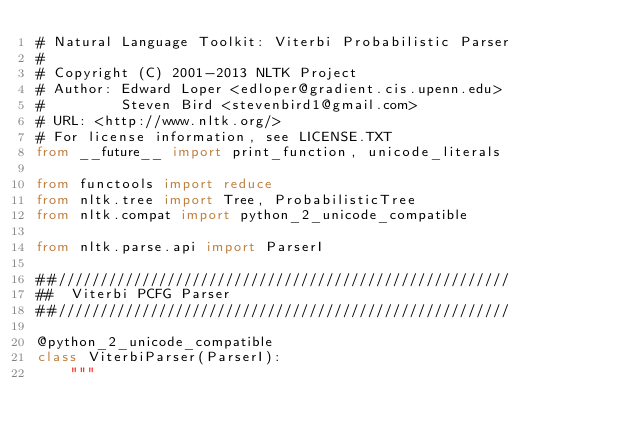<code> <loc_0><loc_0><loc_500><loc_500><_Python_># Natural Language Toolkit: Viterbi Probabilistic Parser
#
# Copyright (C) 2001-2013 NLTK Project
# Author: Edward Loper <edloper@gradient.cis.upenn.edu>
#         Steven Bird <stevenbird1@gmail.com>
# URL: <http://www.nltk.org/>
# For license information, see LICENSE.TXT
from __future__ import print_function, unicode_literals

from functools import reduce
from nltk.tree import Tree, ProbabilisticTree
from nltk.compat import python_2_unicode_compatible

from nltk.parse.api import ParserI

##//////////////////////////////////////////////////////
##  Viterbi PCFG Parser
##//////////////////////////////////////////////////////

@python_2_unicode_compatible
class ViterbiParser(ParserI):
    """</code> 